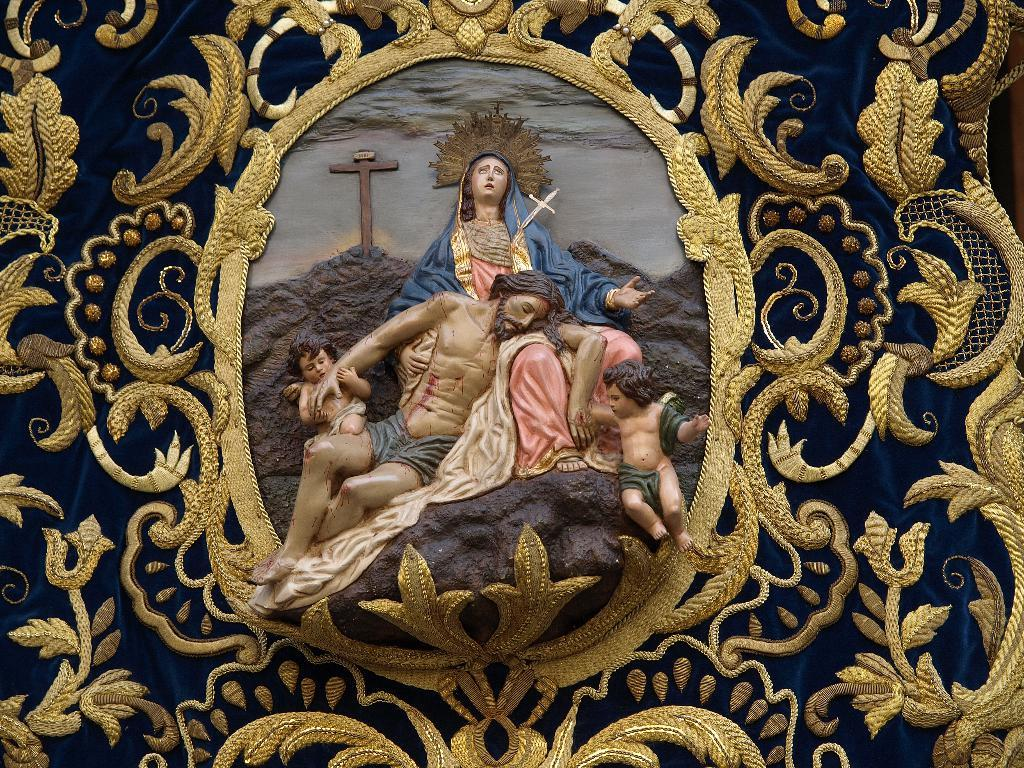What subjects are depicted as statues in the image? There are statues of two persons and two kids in the image. What religious symbol can be seen in the image? There is a Christianity symbol in the image. What type of background is present in the image? There is a designed cloth in the background of the image. How many chairs are visible in the image? There are no chairs visible in the image. What type of hands can be seen interacting with the statues in the image? The statues are not interacting with any hands, as they are inanimate objects. 